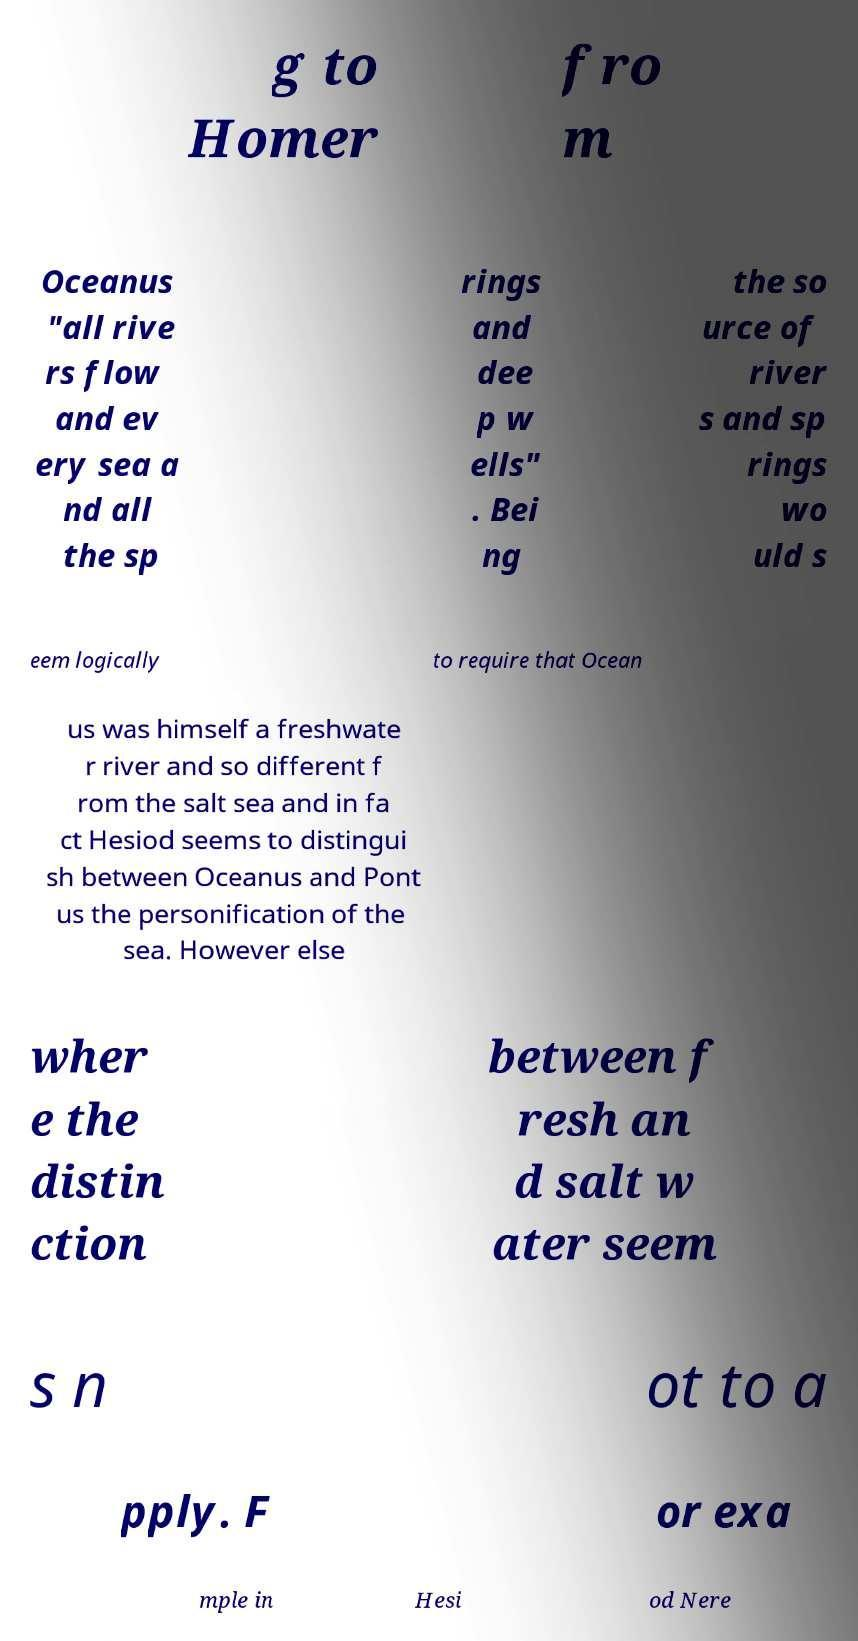There's text embedded in this image that I need extracted. Can you transcribe it verbatim? g to Homer fro m Oceanus "all rive rs flow and ev ery sea a nd all the sp rings and dee p w ells" . Bei ng the so urce of river s and sp rings wo uld s eem logically to require that Ocean us was himself a freshwate r river and so different f rom the salt sea and in fa ct Hesiod seems to distingui sh between Oceanus and Pont us the personification of the sea. However else wher e the distin ction between f resh an d salt w ater seem s n ot to a pply. F or exa mple in Hesi od Nere 